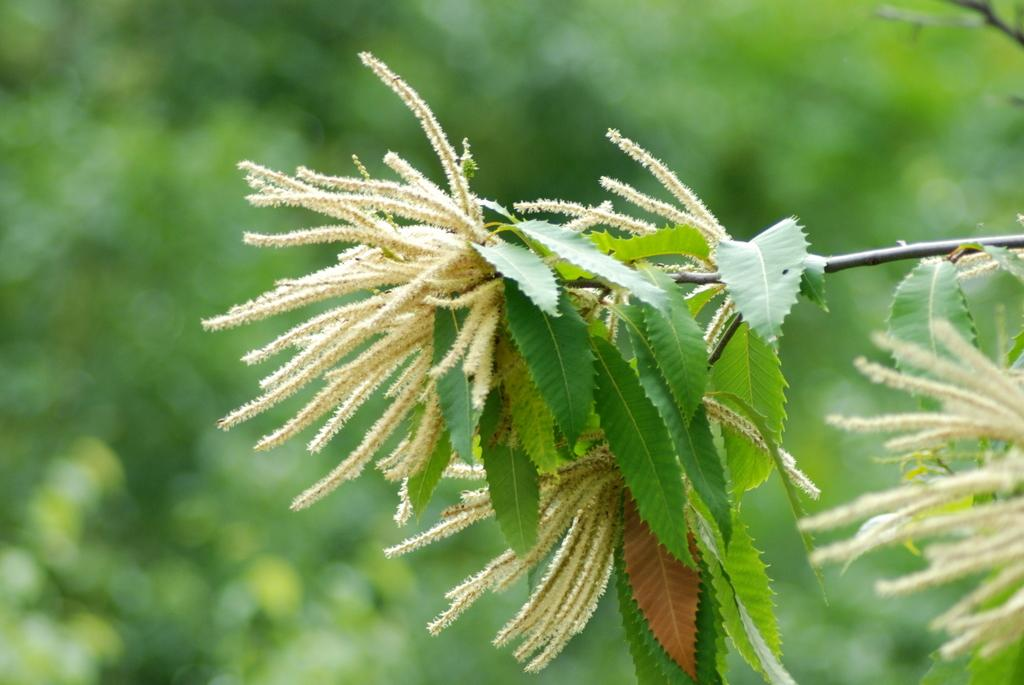What is the main subject in the image? There is a tree in the image. What else can be seen in the image besides the tree? There are white objects in the image, possibly flowers. What color is the background of the image? The background of the image is green. How is the image blurred? The image is blurred in the background. Can you hear the bells ringing in the image? There are no bells present in the image, so it is not possible to hear them ringing. 